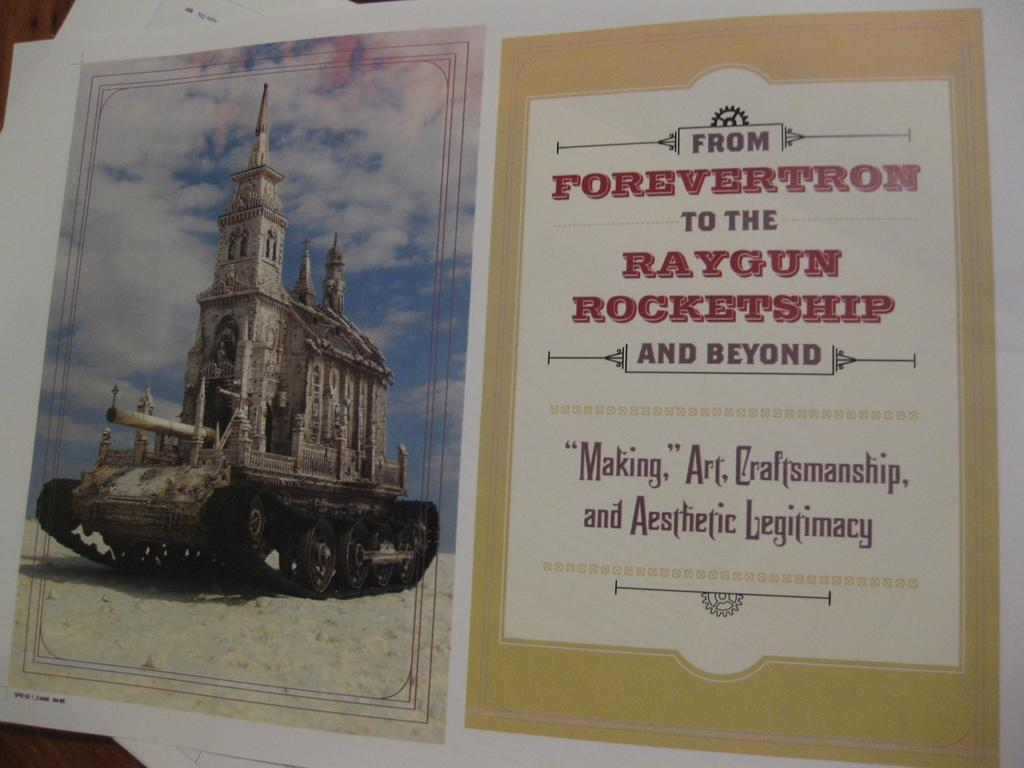<image>
Give a short and clear explanation of the subsequent image. Paper about from forevertron to the raygun rocketship and beyond. 